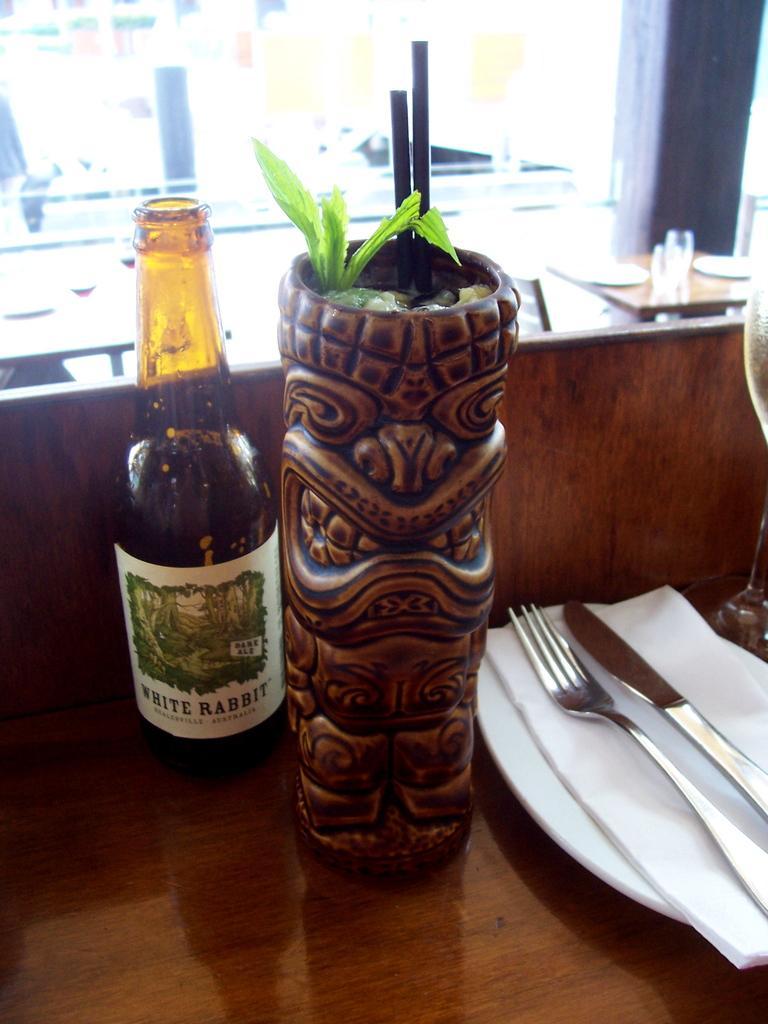Can you describe this image briefly? There is a bottle,flower vase,plate,tissue,fork,knife on a table. In the background we can see Table,glasses and a chair. 